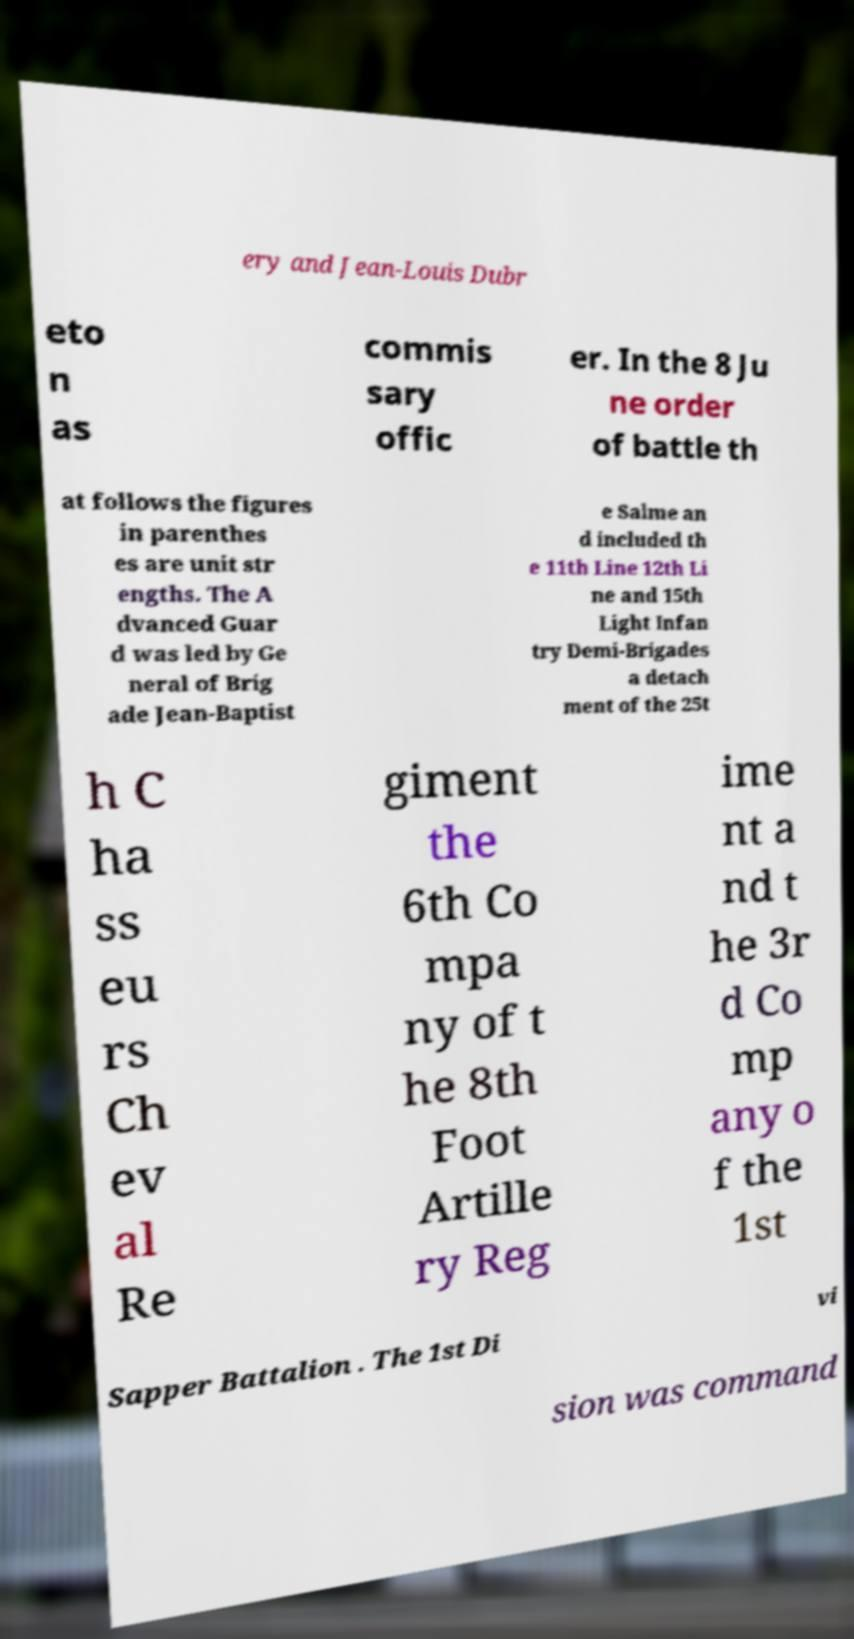What messages or text are displayed in this image? I need them in a readable, typed format. ery and Jean-Louis Dubr eto n as commis sary offic er. In the 8 Ju ne order of battle th at follows the figures in parenthes es are unit str engths. The A dvanced Guar d was led by Ge neral of Brig ade Jean-Baptist e Salme an d included th e 11th Line 12th Li ne and 15th Light Infan try Demi-Brigades a detach ment of the 25t h C ha ss eu rs Ch ev al Re giment the 6th Co mpa ny of t he 8th Foot Artille ry Reg ime nt a nd t he 3r d Co mp any o f the 1st Sapper Battalion . The 1st Di vi sion was command 